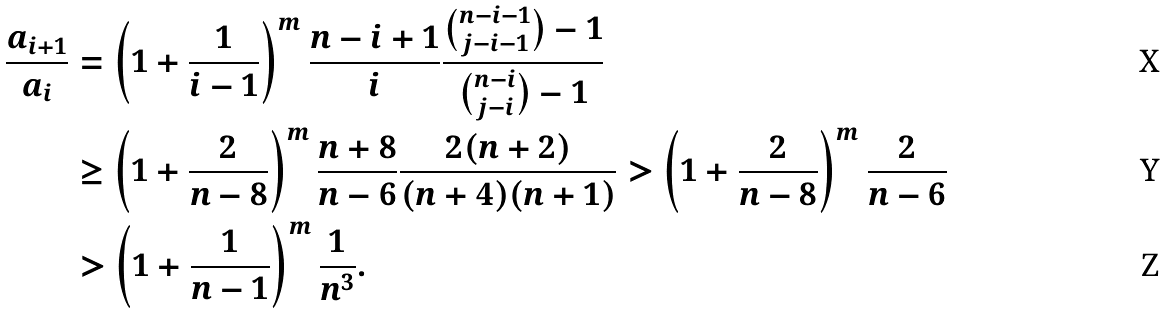Convert formula to latex. <formula><loc_0><loc_0><loc_500><loc_500>\frac { a _ { i + 1 } } { a _ { i } } & = \left ( 1 + \frac { 1 } { i - 1 } \right ) ^ { m } \frac { n - i + 1 } { i } \frac { \binom { n - i - 1 } { j - i - 1 } - 1 } { \binom { n - i } { j - i } - 1 } \\ & \geq \left ( 1 + \frac { 2 } { n - 8 } \right ) ^ { m } \frac { n + 8 } { n - 6 } \frac { 2 ( n + 2 ) } { ( n + 4 ) ( n + 1 ) } > \left ( 1 + \frac { 2 } { n - 8 } \right ) ^ { m } \frac { 2 } { n - 6 } \\ & > \left ( 1 + \frac { 1 } { n - 1 } \right ) ^ { m } \frac { 1 } { n ^ { 3 } } .</formula> 